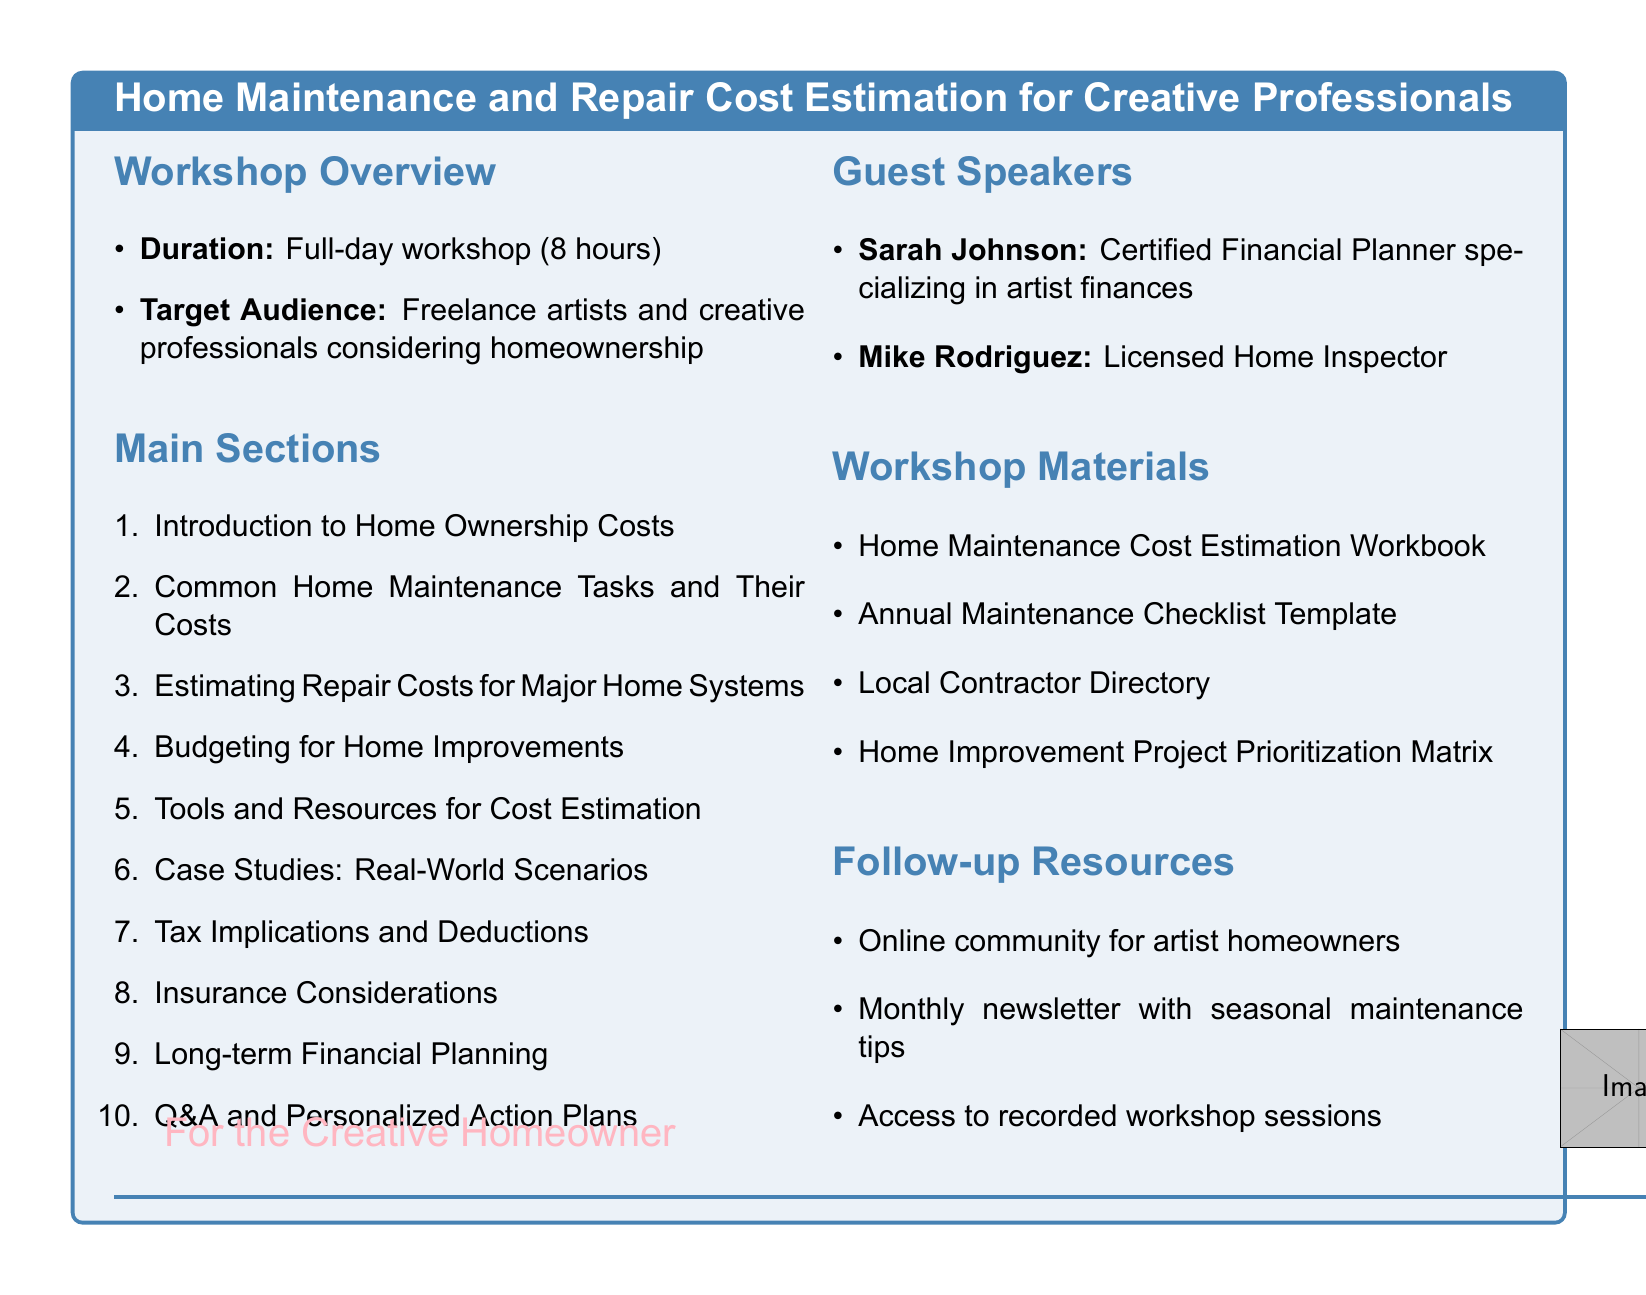What is the title of the workshop? The title of the workshop is mentioned at the beginning of the document.
Answer: Home Maintenance and Repair Cost Estimation for Creative Professionals How many hours does the workshop last? The duration of the workshop is specified clearly in the overview section.
Answer: 8 hours Who is the target audience for the workshop? The target audience is defined in the workshop overview section.
Answer: Freelance artists and creative professionals considering homeownership Name one guest speaker and their title. The guest speakers and their titles are listed in the guest speakers section.
Answer: Sarah Johnson, Certified Financial Planner specializing in artist finances What is one resource provided in the workshop materials? The workshop materials section lists items included in the workshop.
Answer: Home Maintenance Cost Estimation Workbook Which section covers budgeting for home improvements? The sections of the workshop are numbered, allowing easy identification of each topic.
Answer: Budgeting for Home Improvements What type of planning is discussed in the last section? The last section deals with specific long-term financial aspects of home ownership.
Answer: Long-term Financial Planning What kind of follow-up resource is mentioned? The follow-up resources provide information about the additional support attendees can access after the workshop.
Answer: Online community for artist homeowners 